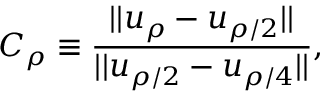<formula> <loc_0><loc_0><loc_500><loc_500>C _ { \rho } \equiv \frac { | | u _ { \rho } - u _ { \rho / 2 } | | } { | | u _ { \rho / 2 } - u _ { \rho / 4 } | | } ,</formula> 